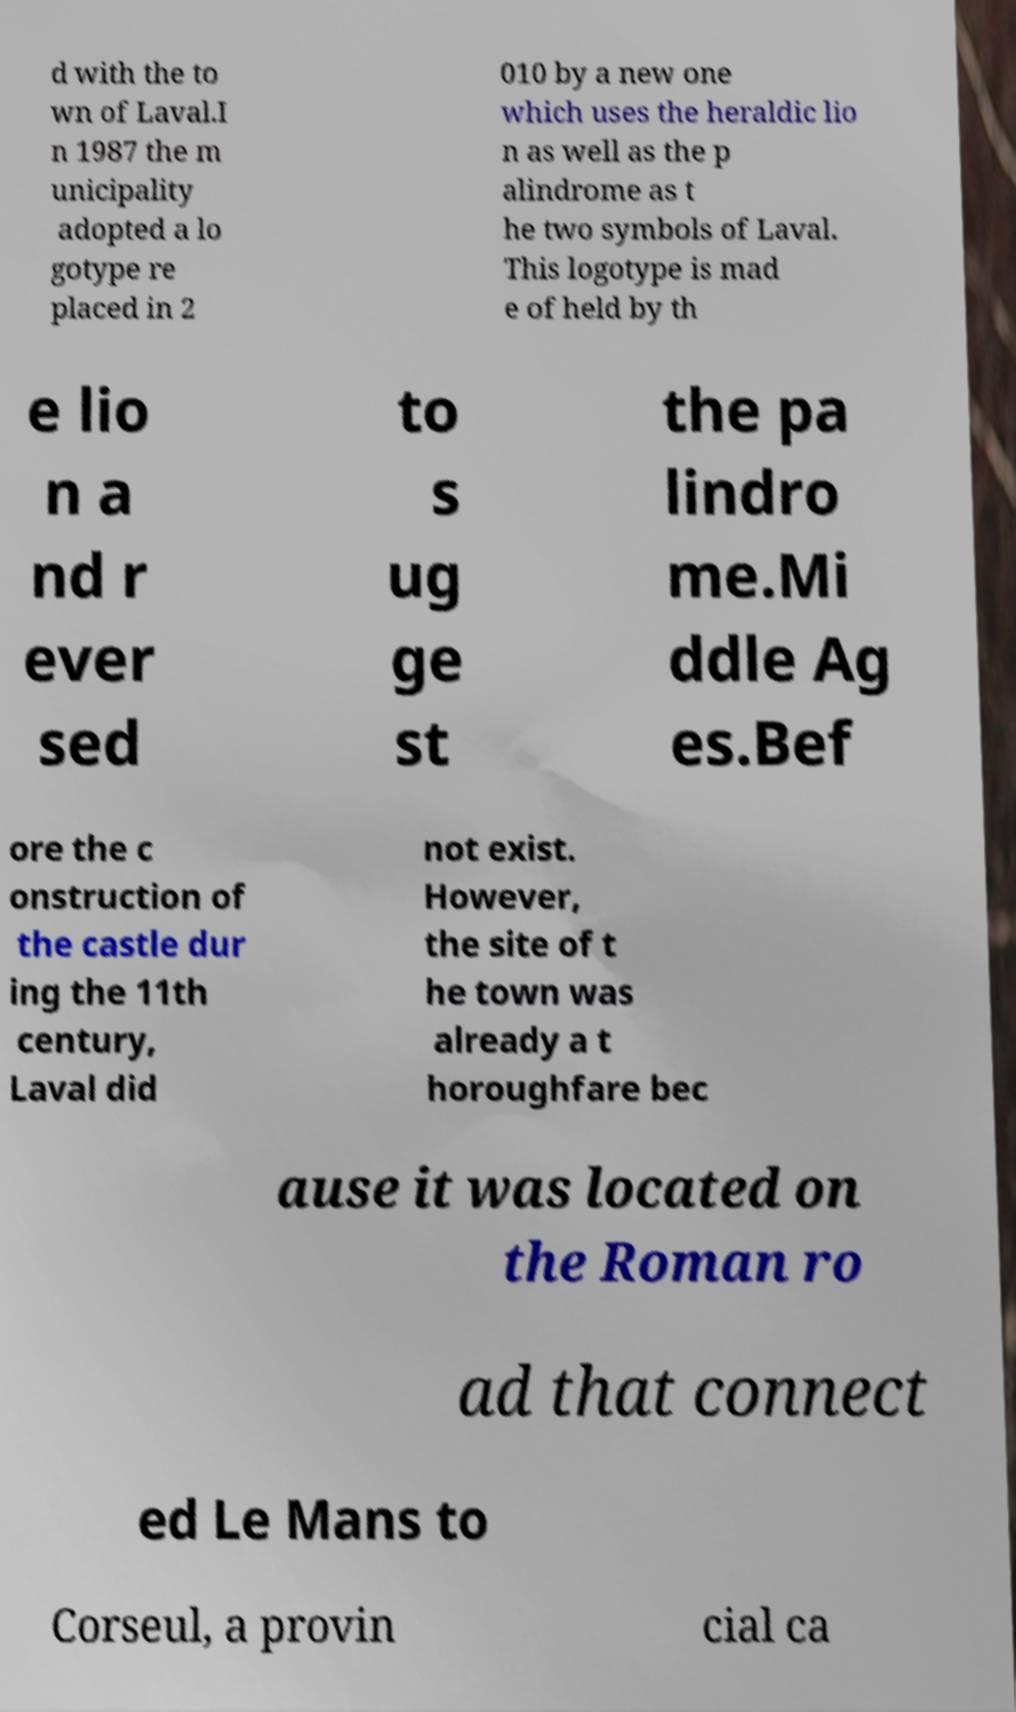Could you extract and type out the text from this image? d with the to wn of Laval.I n 1987 the m unicipality adopted a lo gotype re placed in 2 010 by a new one which uses the heraldic lio n as well as the p alindrome as t he two symbols of Laval. This logotype is mad e of held by th e lio n a nd r ever sed to s ug ge st the pa lindro me.Mi ddle Ag es.Bef ore the c onstruction of the castle dur ing the 11th century, Laval did not exist. However, the site of t he town was already a t horoughfare bec ause it was located on the Roman ro ad that connect ed Le Mans to Corseul, a provin cial ca 